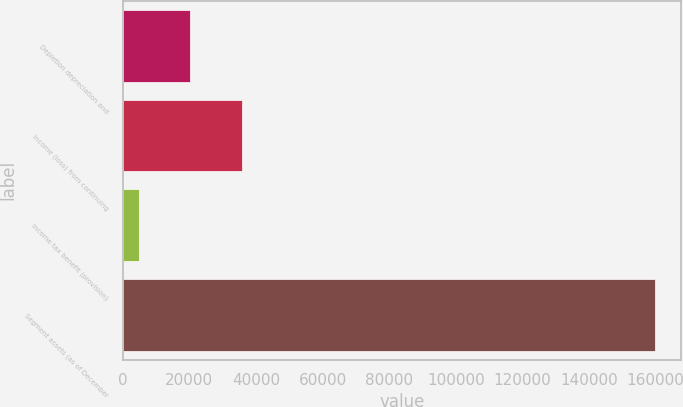Convert chart to OTSL. <chart><loc_0><loc_0><loc_500><loc_500><bar_chart><fcel>Depletion depreciation and<fcel>Income (loss) from continuing<fcel>Income tax benefit (provision)<fcel>Segment assets (as of December<nl><fcel>20238.9<fcel>35739.8<fcel>4738<fcel>159747<nl></chart> 